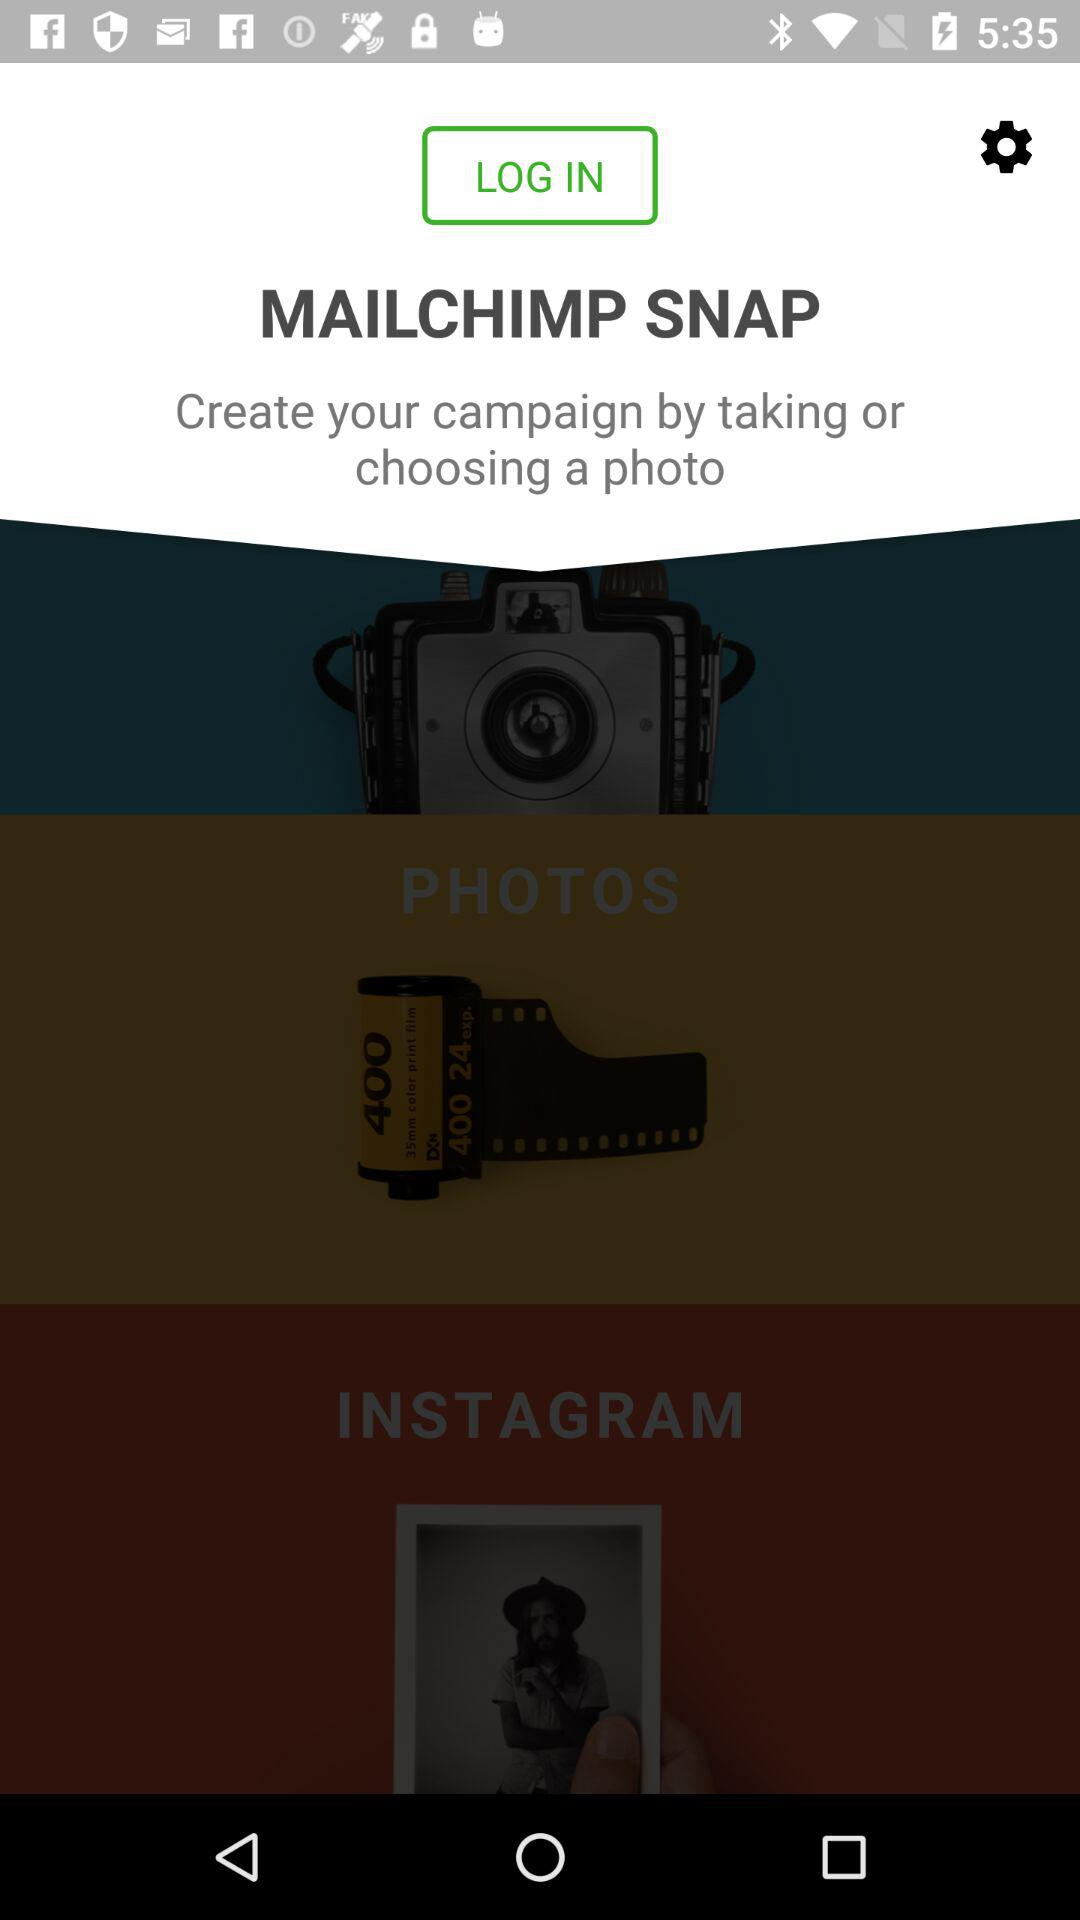What is the application name? The application name is "MAILCHIMP SNAP". 